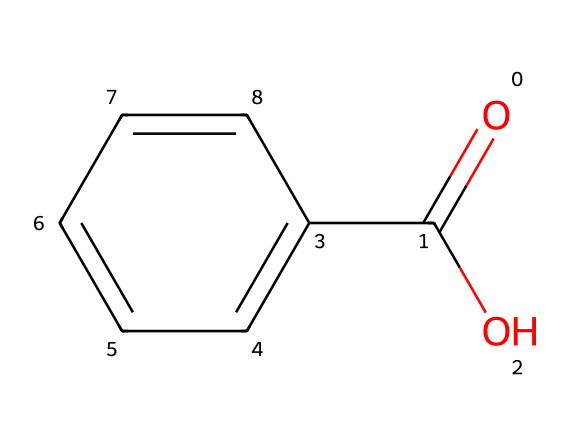What is the common name of the substance represented by this chemical structure? The SMILES representation corresponds to benzoic acid, which is a known food preservative. The structure indicates a carboxylic acid (due to the -COOH group) attached to a benzene ring, confirming its identity as benzoic acid.
Answer: benzoic acid How many carbon atoms are in the chemical structure? The structure has a total of 7 carbon atoms: one from the carboxylic acid group and six from the benzene ring. Counting them gives 7 overall.
Answer: 7 What functional group is present in this chemical? The presence of the -COOH group indicates that the functional group in benzoic acid is a carboxyl group. This group is responsible for its acidic properties and preservation abilities.
Answer: carboxyl group What is the molecular formula of benzoic acid? By analyzing the structure and counting the elements: 7 carbon (C), 6 hydrogen (H), and 2 oxygen (O) yields the molecular formula C7H6O2.
Answer: C7H6O2 Can benzoic acid effectively inhibit the growth of bacteria? Benzoic acid is known for its antimicrobial properties, particularly effective against various bacteria and fungi, which confirms its use as a food preservative.
Answer: yes What type of bonding is mainly responsible for the stability of the benzene ring in this structure? The stability of the benzene ring is primarily due to resonance, which involves delocalized electrons forming strong bonds within the aromatic system, contributing to its stability and durability.
Answer: resonance 